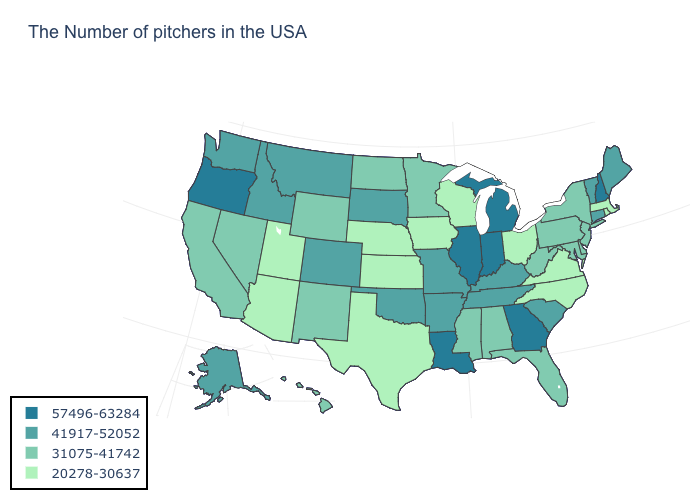How many symbols are there in the legend?
Quick response, please. 4. What is the value of New Hampshire?
Concise answer only. 57496-63284. Among the states that border New Hampshire , which have the lowest value?
Quick response, please. Massachusetts. What is the highest value in the West ?
Give a very brief answer. 57496-63284. Name the states that have a value in the range 20278-30637?
Keep it brief. Massachusetts, Rhode Island, Virginia, North Carolina, Ohio, Wisconsin, Iowa, Kansas, Nebraska, Texas, Utah, Arizona. What is the value of Utah?
Give a very brief answer. 20278-30637. What is the highest value in the West ?
Answer briefly. 57496-63284. What is the lowest value in the Northeast?
Keep it brief. 20278-30637. Among the states that border South Dakota , does Nebraska have the highest value?
Give a very brief answer. No. Name the states that have a value in the range 31075-41742?
Give a very brief answer. New York, New Jersey, Delaware, Maryland, Pennsylvania, West Virginia, Florida, Alabama, Mississippi, Minnesota, North Dakota, Wyoming, New Mexico, Nevada, California, Hawaii. Name the states that have a value in the range 57496-63284?
Answer briefly. New Hampshire, Georgia, Michigan, Indiana, Illinois, Louisiana, Oregon. Does New Jersey have the lowest value in the Northeast?
Quick response, please. No. Is the legend a continuous bar?
Keep it brief. No. Does Indiana have the highest value in the USA?
Quick response, please. Yes. Does the first symbol in the legend represent the smallest category?
Be succinct. No. 